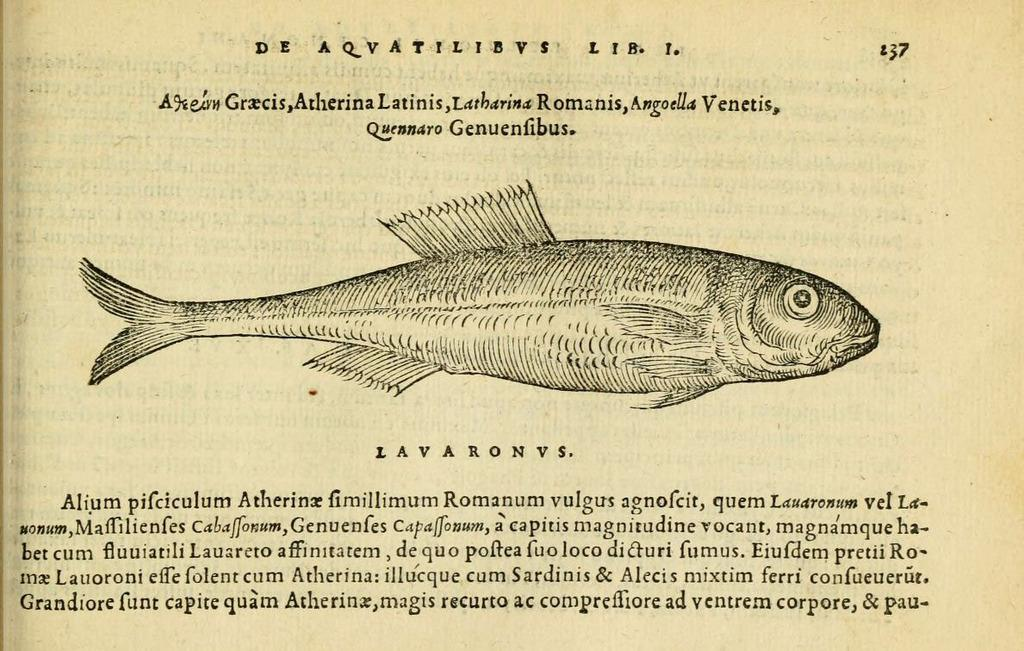What is the main subject of the image? The main subject of the image is a picture of a fish. Is there any text associated with the image? Yes, there is text at the bottom of the image. What type of ball is being used to catch the fish in the image? There is no ball present in the image; it features a picture of a fish and text at the bottom. 